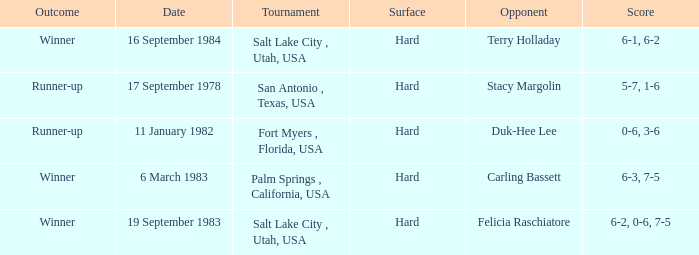What was the outcome of the match against Stacy Margolin? Runner-up. 